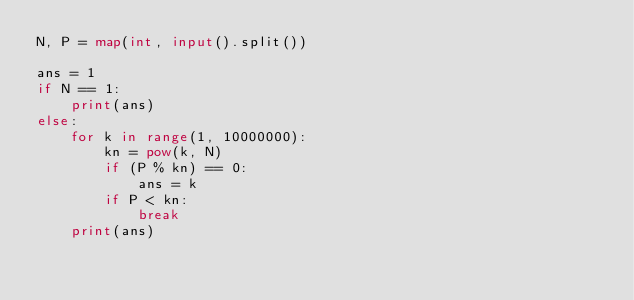<code> <loc_0><loc_0><loc_500><loc_500><_Python_>N, P = map(int, input().split())

ans = 1
if N == 1:
    print(ans)
else:
    for k in range(1, 10000000):
        kn = pow(k, N)
        if (P % kn) == 0:
            ans = k
        if P < kn:
            break
    print(ans)
</code> 